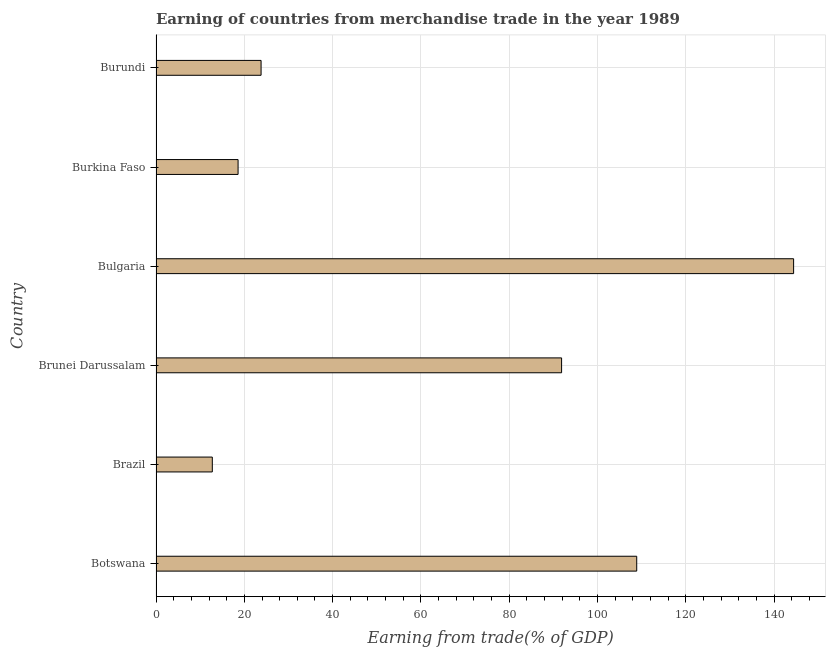Does the graph contain any zero values?
Your response must be concise. No. What is the title of the graph?
Keep it short and to the point. Earning of countries from merchandise trade in the year 1989. What is the label or title of the X-axis?
Provide a short and direct response. Earning from trade(% of GDP). What is the label or title of the Y-axis?
Provide a short and direct response. Country. What is the earning from merchandise trade in Brazil?
Ensure brevity in your answer.  12.75. Across all countries, what is the maximum earning from merchandise trade?
Ensure brevity in your answer.  144.39. Across all countries, what is the minimum earning from merchandise trade?
Provide a short and direct response. 12.75. In which country was the earning from merchandise trade minimum?
Your answer should be very brief. Brazil. What is the sum of the earning from merchandise trade?
Your response must be concise. 400.21. What is the difference between the earning from merchandise trade in Brazil and Bulgaria?
Provide a short and direct response. -131.64. What is the average earning from merchandise trade per country?
Your answer should be compact. 66.7. What is the median earning from merchandise trade?
Provide a succinct answer. 57.82. In how many countries, is the earning from merchandise trade greater than 36 %?
Offer a terse response. 3. What is the ratio of the earning from merchandise trade in Bulgaria to that in Burkina Faso?
Offer a very short reply. 7.77. Is the earning from merchandise trade in Brazil less than that in Burundi?
Give a very brief answer. Yes. Is the difference between the earning from merchandise trade in Brazil and Burundi greater than the difference between any two countries?
Give a very brief answer. No. What is the difference between the highest and the second highest earning from merchandise trade?
Your answer should be very brief. 35.53. What is the difference between the highest and the lowest earning from merchandise trade?
Offer a terse response. 131.64. Are all the bars in the graph horizontal?
Keep it short and to the point. Yes. What is the difference between two consecutive major ticks on the X-axis?
Keep it short and to the point. 20. Are the values on the major ticks of X-axis written in scientific E-notation?
Provide a short and direct response. No. What is the Earning from trade(% of GDP) of Botswana?
Make the answer very short. 108.86. What is the Earning from trade(% of GDP) of Brazil?
Provide a short and direct response. 12.75. What is the Earning from trade(% of GDP) in Brunei Darussalam?
Your response must be concise. 91.84. What is the Earning from trade(% of GDP) of Bulgaria?
Give a very brief answer. 144.39. What is the Earning from trade(% of GDP) of Burkina Faso?
Give a very brief answer. 18.58. What is the Earning from trade(% of GDP) in Burundi?
Give a very brief answer. 23.79. What is the difference between the Earning from trade(% of GDP) in Botswana and Brazil?
Your answer should be compact. 96.11. What is the difference between the Earning from trade(% of GDP) in Botswana and Brunei Darussalam?
Ensure brevity in your answer.  17.01. What is the difference between the Earning from trade(% of GDP) in Botswana and Bulgaria?
Make the answer very short. -35.53. What is the difference between the Earning from trade(% of GDP) in Botswana and Burkina Faso?
Provide a succinct answer. 90.28. What is the difference between the Earning from trade(% of GDP) in Botswana and Burundi?
Offer a very short reply. 85.07. What is the difference between the Earning from trade(% of GDP) in Brazil and Brunei Darussalam?
Give a very brief answer. -79.1. What is the difference between the Earning from trade(% of GDP) in Brazil and Bulgaria?
Keep it short and to the point. -131.64. What is the difference between the Earning from trade(% of GDP) in Brazil and Burkina Faso?
Your answer should be compact. -5.83. What is the difference between the Earning from trade(% of GDP) in Brazil and Burundi?
Offer a very short reply. -11.04. What is the difference between the Earning from trade(% of GDP) in Brunei Darussalam and Bulgaria?
Keep it short and to the point. -52.54. What is the difference between the Earning from trade(% of GDP) in Brunei Darussalam and Burkina Faso?
Offer a very short reply. 73.26. What is the difference between the Earning from trade(% of GDP) in Brunei Darussalam and Burundi?
Ensure brevity in your answer.  68.06. What is the difference between the Earning from trade(% of GDP) in Bulgaria and Burkina Faso?
Provide a short and direct response. 125.81. What is the difference between the Earning from trade(% of GDP) in Bulgaria and Burundi?
Provide a short and direct response. 120.6. What is the difference between the Earning from trade(% of GDP) in Burkina Faso and Burundi?
Provide a short and direct response. -5.21. What is the ratio of the Earning from trade(% of GDP) in Botswana to that in Brazil?
Offer a terse response. 8.54. What is the ratio of the Earning from trade(% of GDP) in Botswana to that in Brunei Darussalam?
Your response must be concise. 1.19. What is the ratio of the Earning from trade(% of GDP) in Botswana to that in Bulgaria?
Offer a very short reply. 0.75. What is the ratio of the Earning from trade(% of GDP) in Botswana to that in Burkina Faso?
Keep it short and to the point. 5.86. What is the ratio of the Earning from trade(% of GDP) in Botswana to that in Burundi?
Ensure brevity in your answer.  4.58. What is the ratio of the Earning from trade(% of GDP) in Brazil to that in Brunei Darussalam?
Provide a short and direct response. 0.14. What is the ratio of the Earning from trade(% of GDP) in Brazil to that in Bulgaria?
Offer a terse response. 0.09. What is the ratio of the Earning from trade(% of GDP) in Brazil to that in Burkina Faso?
Your response must be concise. 0.69. What is the ratio of the Earning from trade(% of GDP) in Brazil to that in Burundi?
Give a very brief answer. 0.54. What is the ratio of the Earning from trade(% of GDP) in Brunei Darussalam to that in Bulgaria?
Offer a very short reply. 0.64. What is the ratio of the Earning from trade(% of GDP) in Brunei Darussalam to that in Burkina Faso?
Your response must be concise. 4.94. What is the ratio of the Earning from trade(% of GDP) in Brunei Darussalam to that in Burundi?
Your answer should be very brief. 3.86. What is the ratio of the Earning from trade(% of GDP) in Bulgaria to that in Burkina Faso?
Give a very brief answer. 7.77. What is the ratio of the Earning from trade(% of GDP) in Bulgaria to that in Burundi?
Make the answer very short. 6.07. What is the ratio of the Earning from trade(% of GDP) in Burkina Faso to that in Burundi?
Ensure brevity in your answer.  0.78. 